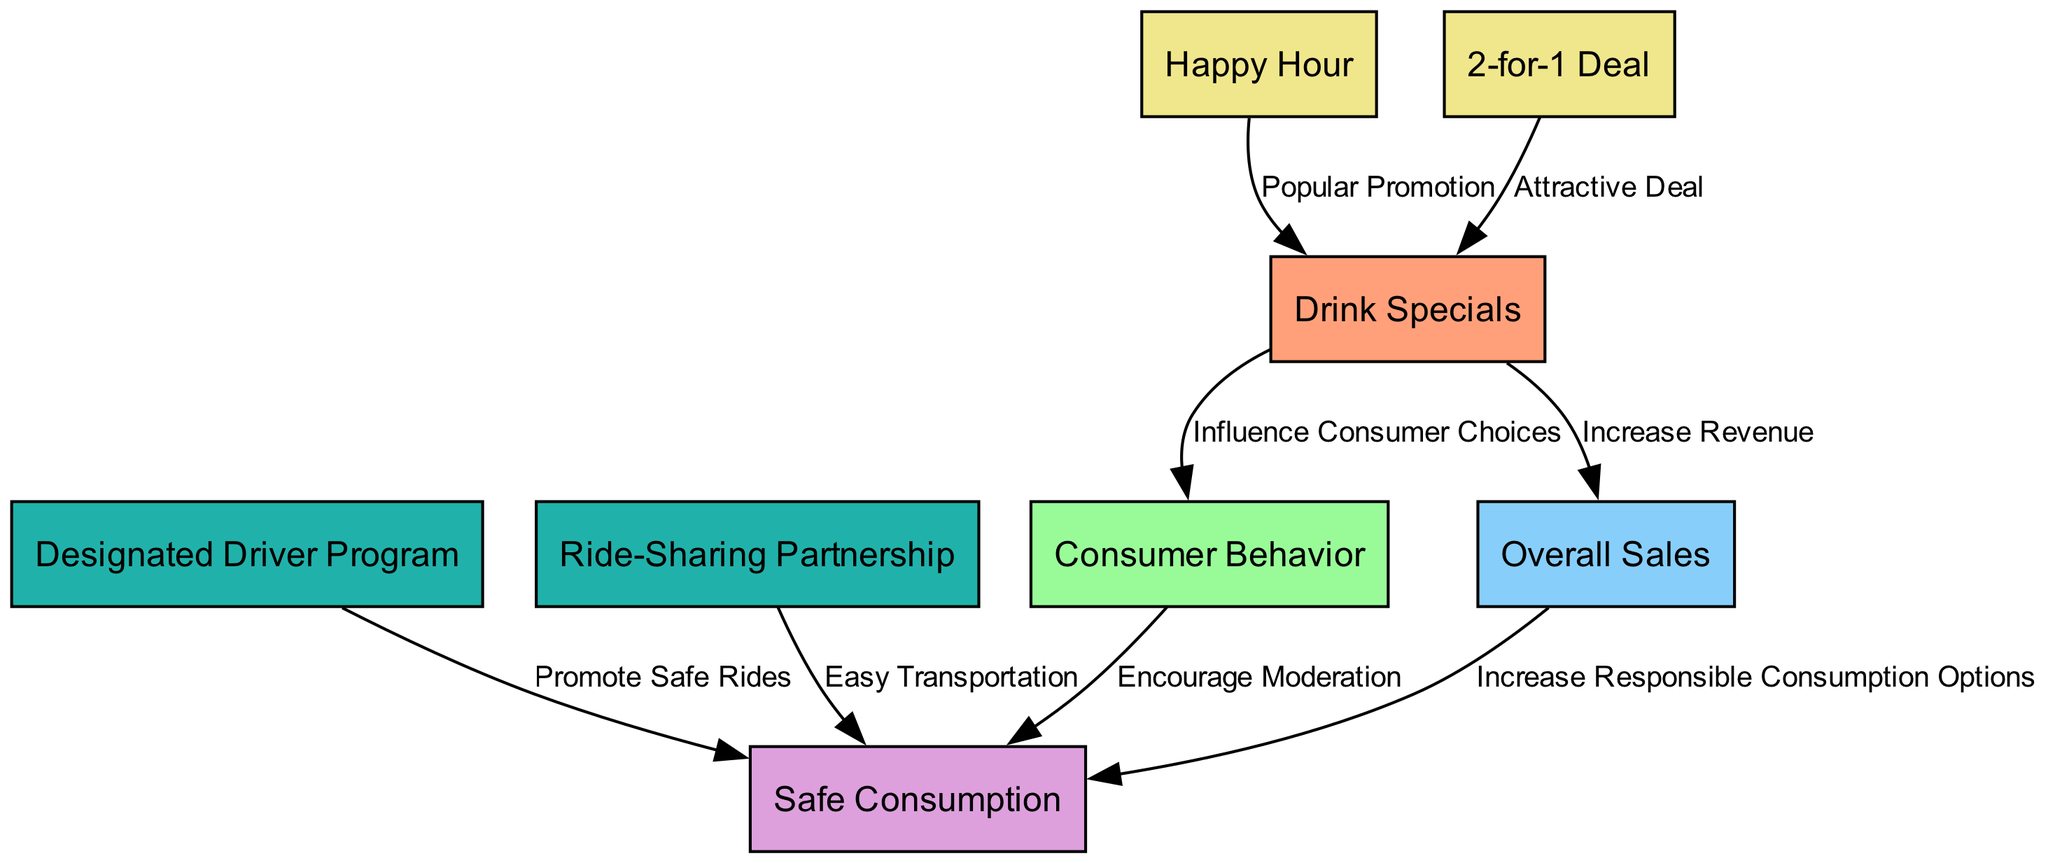What is the primary influence of drink specials on consumer behavior? Drink specials primarily "Influence Consumer Choices" as per the labeled edge in the diagram that connects drink specials to consumer behavior.
Answer: Influence Consumer Choices How many nodes are present in the diagram? By counting the nodes listed, there are eight distinct nodes in the diagram related to drink specials, consumer behavior, overall sales, safe consumption, and various promotions.
Answer: 8 What is an example of a promotion that leads to increased drink specials? The edge labeled "Popular Promotion" connects happy hour to drink specials, indicating that a happy hour is an example that leads to increased drink specials.
Answer: Happy Hour Which strategy is aimed at promoting safe rides? The "Designated Driver Program" node specifically promotes safe rides according to the edge connecting it to safe consumption.
Answer: Designated Driver Program What effect do drink specials have on overall sales? Drink specials are indicated to "Increase Revenue," which is the relationship established by the edge leading from drink specials to overall sales.
Answer: Increase Revenue How do consumer behaviors affect safe consumption? Consumer behavior encourages moderation as indicated by the labeled edge between consumer behavior and safe consumption.
Answer: Encourage Moderation Which promotional strategy is noted for providing easy transportation? The "Ride-Sharing Partnership" is the strategy highlighted in the diagram as providing easy transportation, attached to the safe consumption node.
Answer: Ride-Sharing Partnership What impact do overall sales have on safe consumption options? Overall sales increase responsible consumption options, as demonstrated by the directed edge leading from overall sales to safe consumption.
Answer: Increase Responsible Consumption Options 